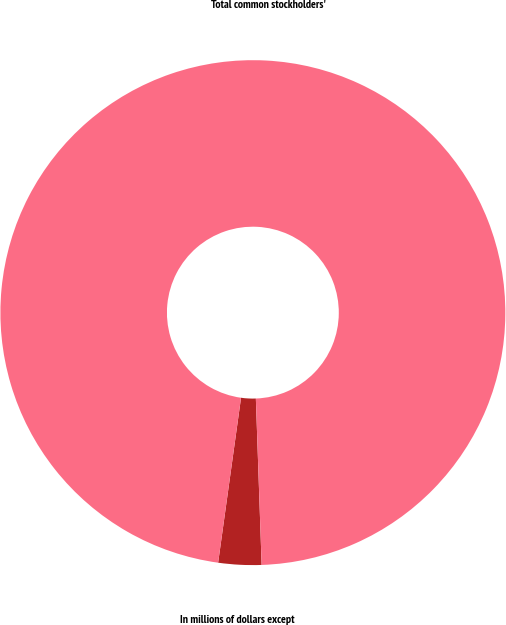Convert chart to OTSL. <chart><loc_0><loc_0><loc_500><loc_500><pie_chart><fcel>In millions of dollars except<fcel>Total common stockholders'<nl><fcel>2.75%<fcel>97.25%<nl></chart> 